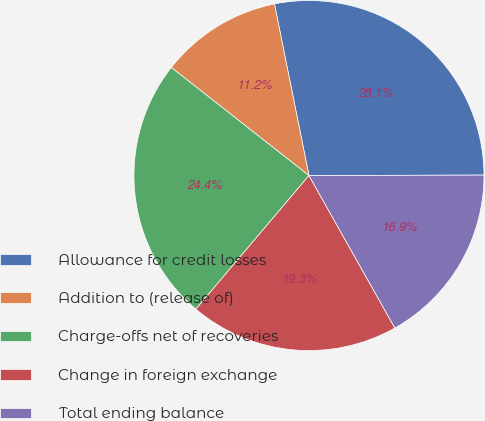Convert chart to OTSL. <chart><loc_0><loc_0><loc_500><loc_500><pie_chart><fcel>Allowance for credit losses<fcel>Addition to (release of)<fcel>Charge-offs net of recoveries<fcel>Change in foreign exchange<fcel>Total ending balance<nl><fcel>28.12%<fcel>11.25%<fcel>24.41%<fcel>19.35%<fcel>16.87%<nl></chart> 